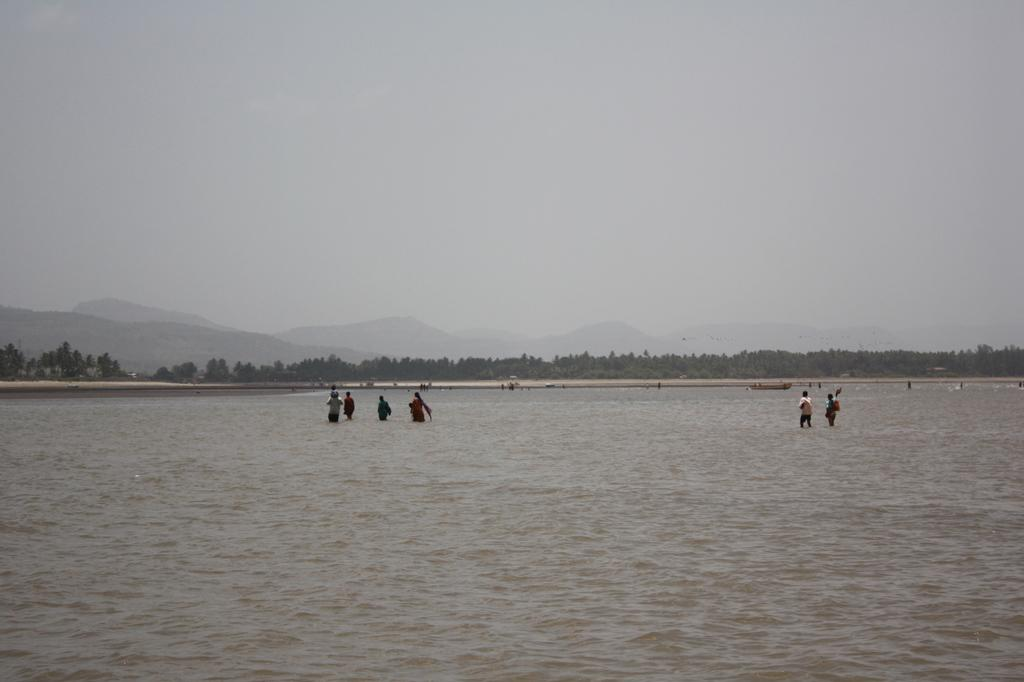What is the primary element present in the image? There is water in the image. What are the people in the image doing? There are persons standing in the water and on the ground. What type of memory can be seen floating in the water in the image? There is no memory present in the image; it is a scene with water, people, trees, mountains, and the sky. What shape is the pancake that is being cooked on the mountain in the image? There is no pancake or cooking activity present in the image. 